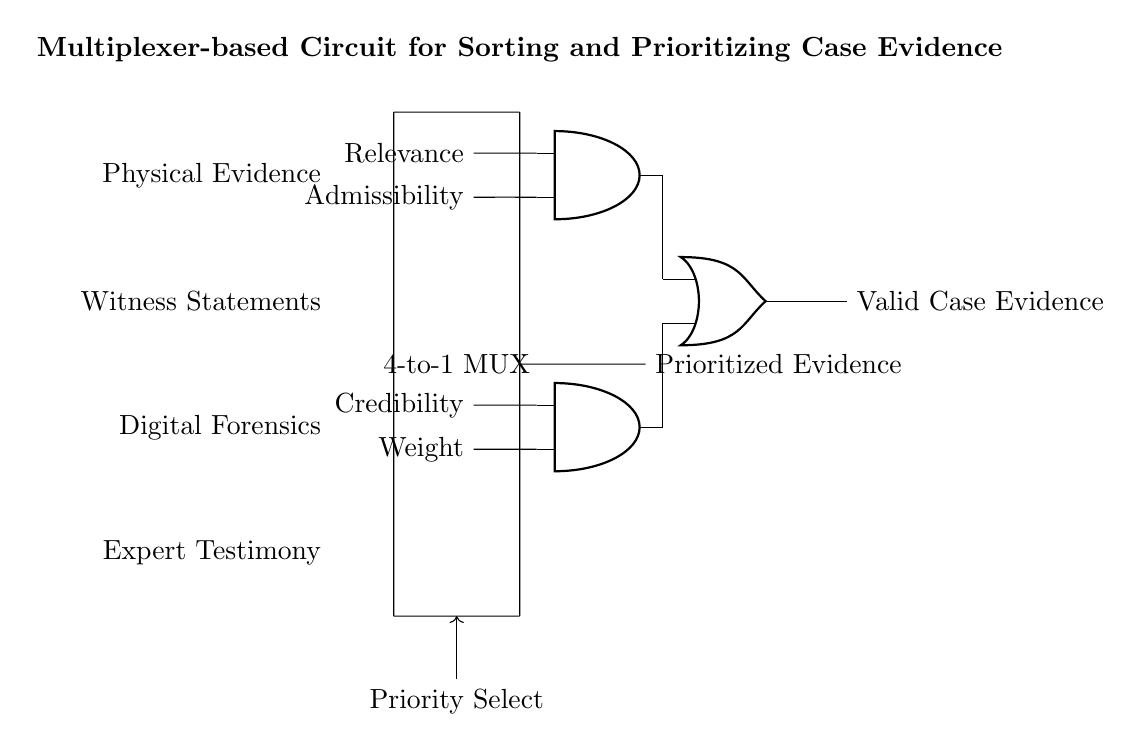What is the type of multiplexer used in this circuit? The circuit diagram specifies a 4-to-1 multiplexer, which allows four input lines to be selected for a single output based on control signals.
Answer: 4-to-1 MUX What are the inputs to the multiplexer? The inputs listed in the diagram are Physical Evidence, Witness Statements, Digital Forensics, and Expert Testimony. These represent the different types of evidence being considered for prioritization.
Answer: Physical Evidence, Witness Statements, Digital Forensics, Expert Testimony What is the output of the multiplexer labeled as? The output of the multiplexer is labeled as Prioritized Evidence, indicating the selected evidence type after considering the priority selection control.
Answer: Prioritized Evidence How many AND gates are present in this circuit? The circuit diagram contains two AND gates, which help validate case evidence based on the relevance, admissibility, credibility, and weight of the evidence before final output.
Answer: 2 What is the purpose of the OR gate in this circuit? The OR gate combines the outputs of the two AND gates, meaning the final output of Valid Case Evidence will be true if either of the AND gates outputs a true signal. This is critical for determining valid evidence irrespective of which validation criteria are met.
Answer: Combine outputs What signals are used for the control of the multiplexer? The control signal is labeled as "Priority Select," indicating that it determines which of the four inputs from the multiplexer is passed to the output based on the importance or priority of the evidence types.
Answer: Priority Select What is the final output of the circuit? The final output is labeled as Valid Case Evidence, which is the conclusive result after considering all validation factors from the AND gates.
Answer: Valid Case Evidence 